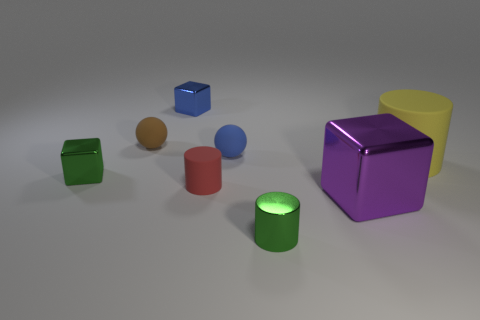What is the material of the other small thing that is the same shape as the small brown thing?
Ensure brevity in your answer.  Rubber. There is a shiny cube that is behind the small blue matte ball; is its color the same as the matte object to the right of the metal cylinder?
Make the answer very short. No. Are there any blue shiny objects that have the same size as the purple block?
Your response must be concise. No. What is the material of the block that is in front of the tiny blue shiny block and on the left side of the big block?
Provide a succinct answer. Metal. What number of matte objects are tiny spheres or blue blocks?
Offer a terse response. 2. There is a tiny blue object that is the same material as the small brown ball; what shape is it?
Make the answer very short. Sphere. How many shiny things are both behind the purple metallic block and right of the tiny blue block?
Offer a very short reply. 0. Are there any other things that have the same shape as the blue shiny object?
Make the answer very short. Yes. There is a shiny block to the right of the small green shiny cylinder; what size is it?
Keep it short and to the point. Large. What number of other things are there of the same color as the big rubber object?
Your response must be concise. 0. 